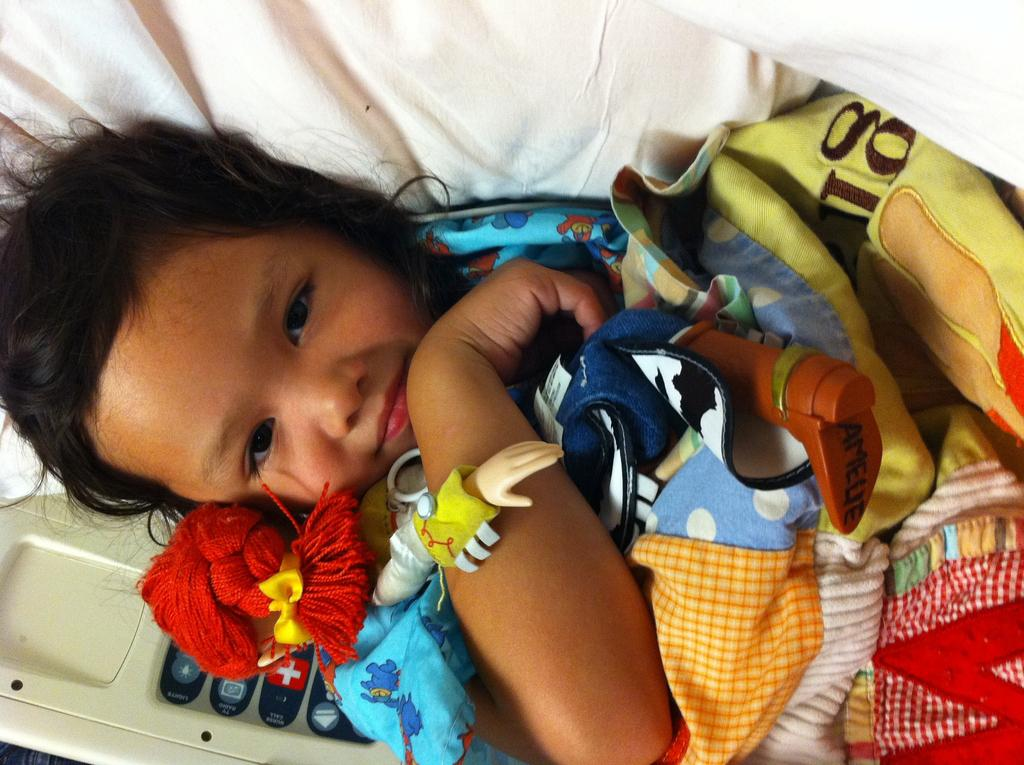<image>
Write a terse but informative summary of the picture. A girl named Amelie holds her doll in her arms. 